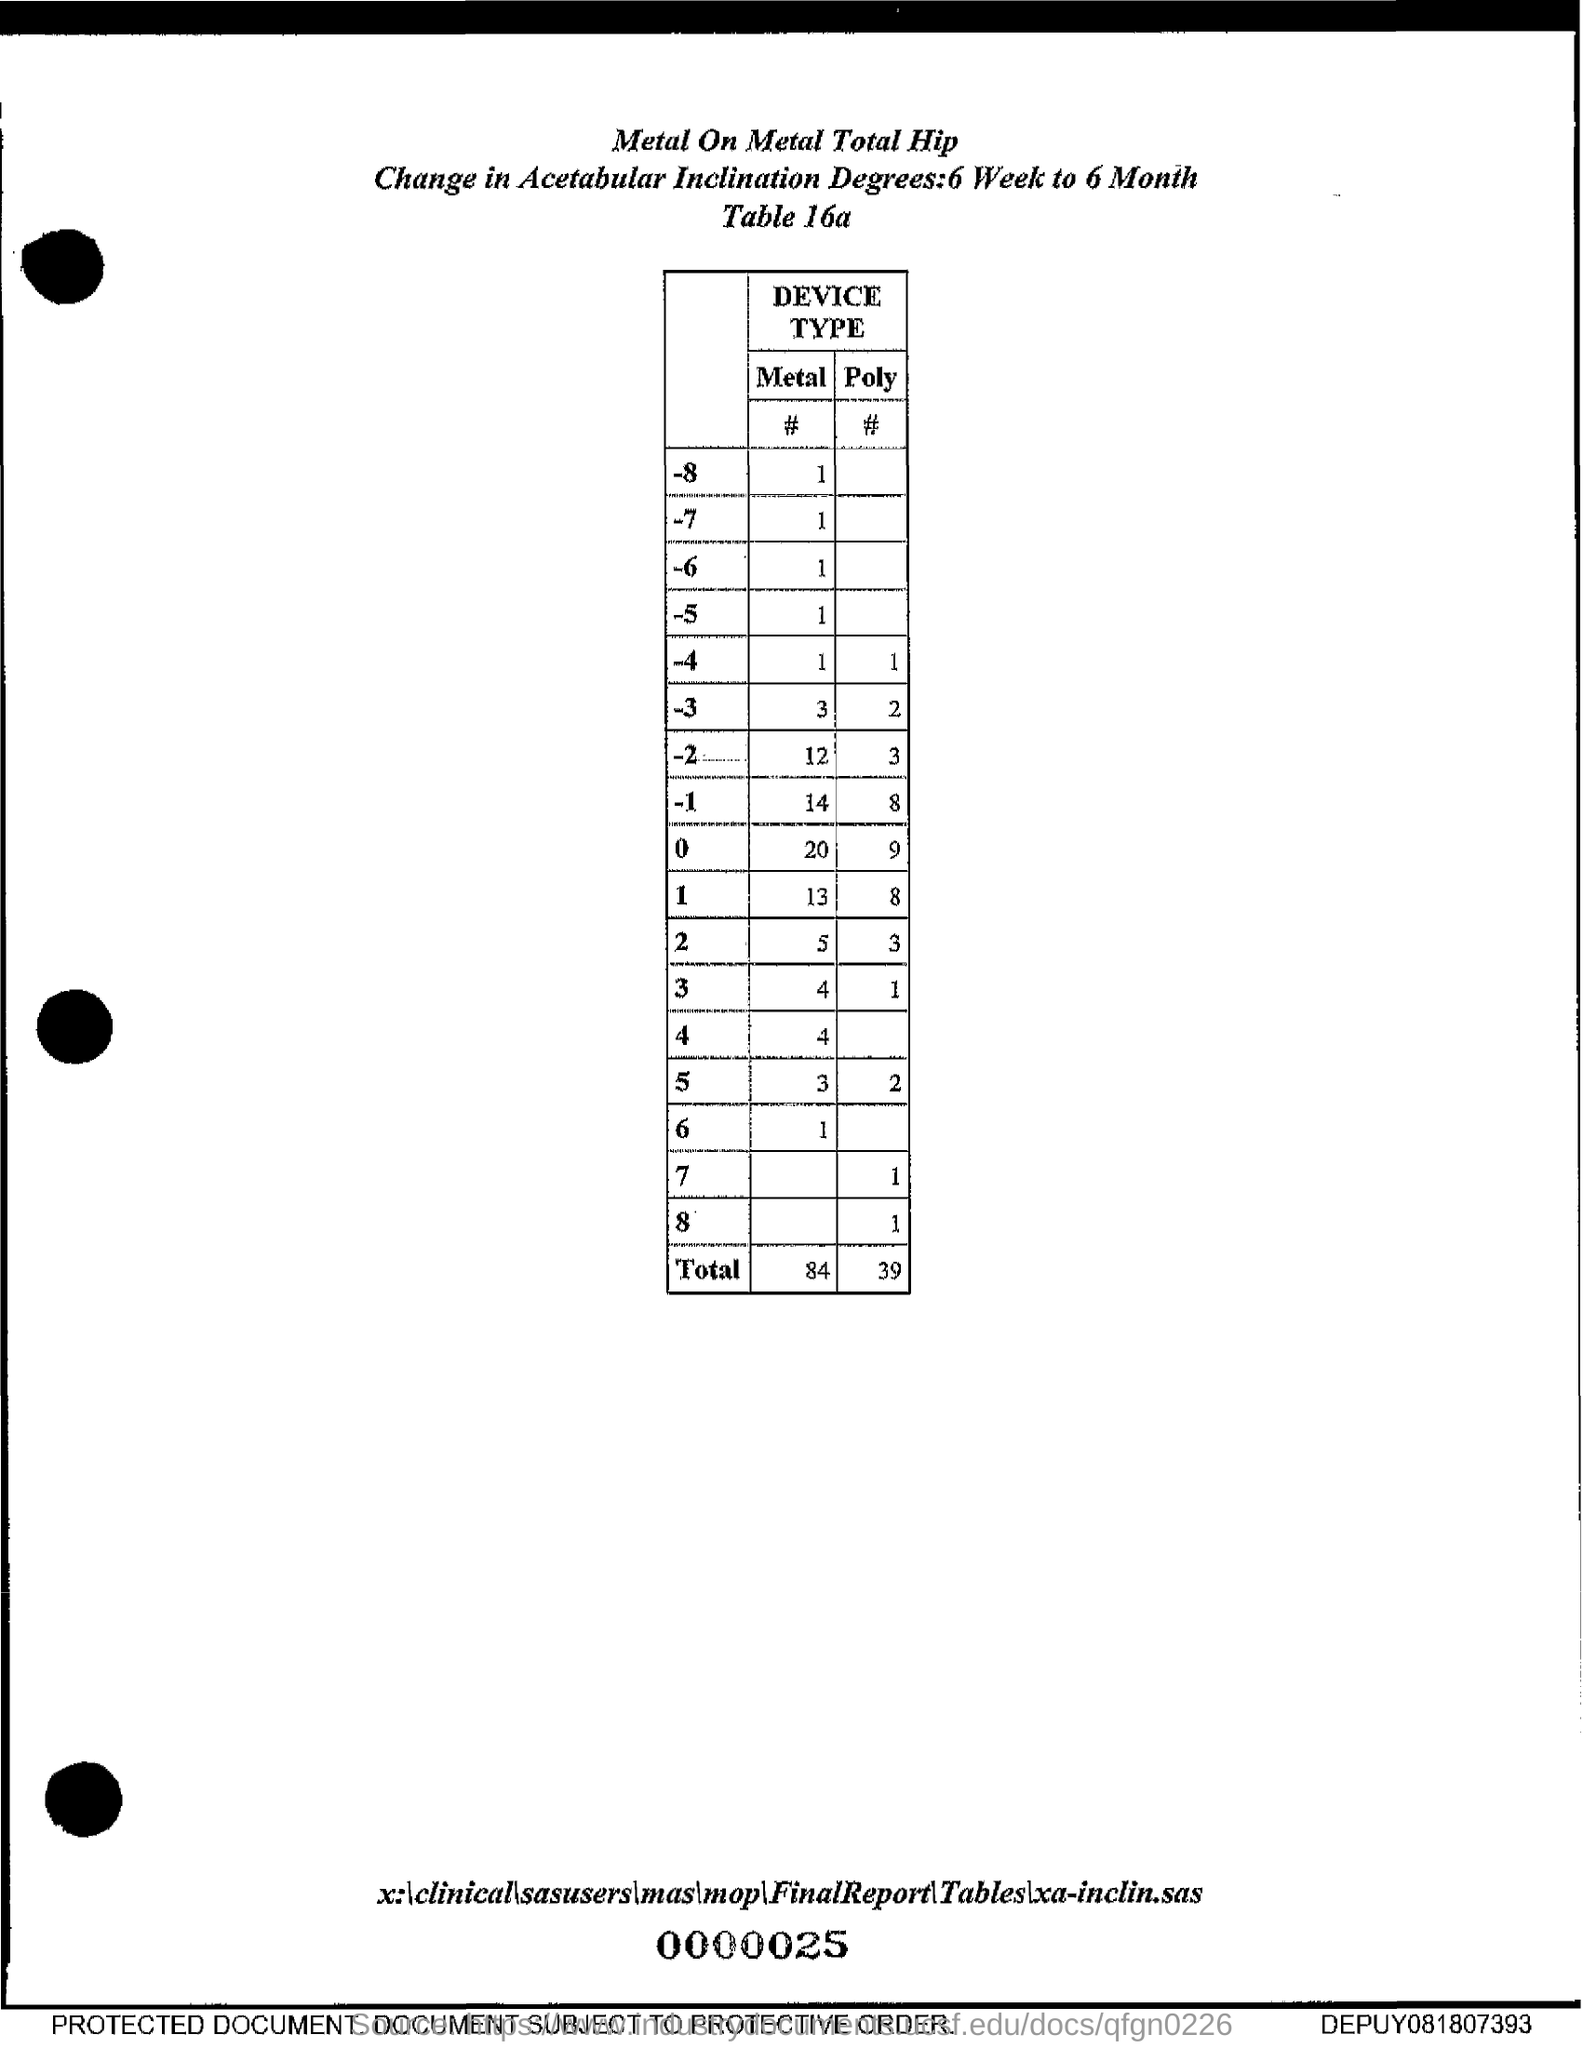Indicate a few pertinent items in this graphic. The total poly number is 39. The total metal number is 84. 